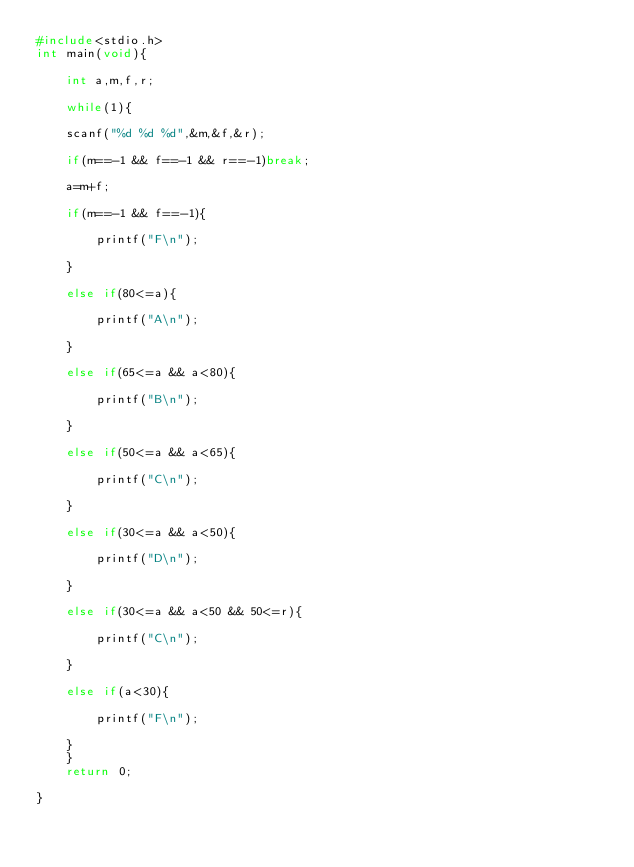Convert code to text. <code><loc_0><loc_0><loc_500><loc_500><_C_>#include<stdio.h>
int main(void){

	int a,m,f,r;

	while(1){

	scanf("%d %d %d",&m,&f,&r);

	if(m==-1 && f==-1 && r==-1)break;

	a=m+f;

	if(m==-1 && f==-1){

		printf("F\n");

	}

	else if(80<=a){

		printf("A\n");

	}

	else if(65<=a && a<80){

		printf("B\n");

	}

	else if(50<=a && a<65){

		printf("C\n");

	}

	else if(30<=a && a<50){

		printf("D\n");

	}

	else if(30<=a && a<50 && 50<=r){

		printf("C\n");

	}

	else if(a<30){

		printf("F\n");

	}
	}
	return 0;

}</code> 